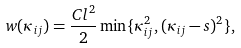Convert formula to latex. <formula><loc_0><loc_0><loc_500><loc_500>w ( \kappa _ { i j } ) = \frac { C l ^ { 2 } } { 2 } \min \{ \kappa _ { i j } ^ { 2 } , ( \kappa _ { i j } - s ) ^ { 2 } \} ,</formula> 